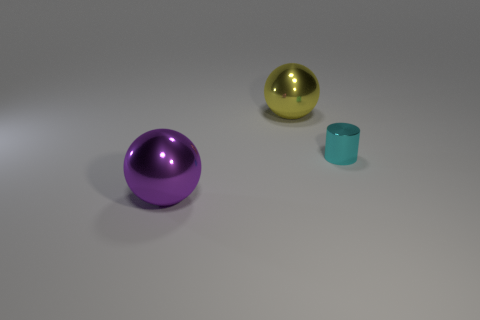Add 1 cyan metallic balls. How many objects exist? 4 Subtract all brown cylinders. How many yellow spheres are left? 1 Subtract 1 cyan cylinders. How many objects are left? 2 Subtract all balls. How many objects are left? 1 Subtract 1 balls. How many balls are left? 1 Subtract all gray spheres. Subtract all brown blocks. How many spheres are left? 2 Subtract all big rubber objects. Subtract all metal balls. How many objects are left? 1 Add 2 large yellow spheres. How many large yellow spheres are left? 3 Add 3 large yellow cubes. How many large yellow cubes exist? 3 